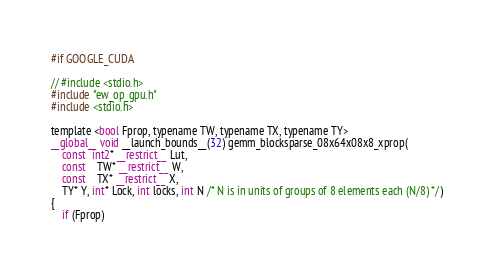<code> <loc_0><loc_0><loc_500><loc_500><_Cuda_>
#if GOOGLE_CUDA

// #include <stdio.h>
#include "ew_op_gpu.h"
#include <stdio.h>

template <bool Fprop, typename TW, typename TX, typename TY>
__global__ void __launch_bounds__(32) gemm_blocksparse_08x64x08x8_xprop(
    const  int2* __restrict__ Lut,
    const    TW* __restrict__ W,
    const    TX* __restrict__ X,
    TY* Y, int* Lock, int locks, int N /* N is in units of groups of 8 elements each (N/8) */)
{
    if (Fprop)</code> 